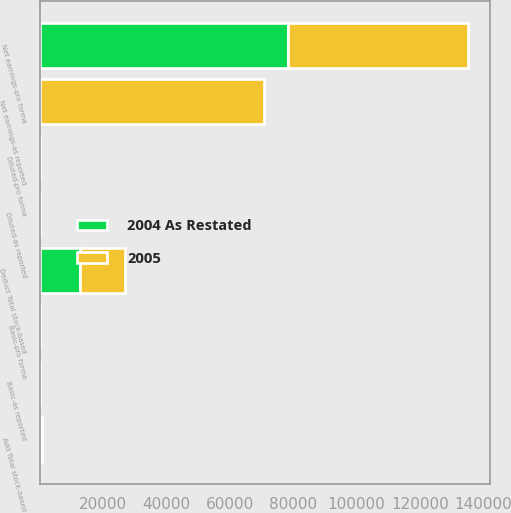Convert chart to OTSL. <chart><loc_0><loc_0><loc_500><loc_500><stacked_bar_chart><ecel><fcel>Net earnings-as reported<fcel>Add Total stock-based<fcel>Deduct Total stock-based<fcel>Net earnings-pro forma<fcel>Basic-as reported<fcel>Diluted-as reported<fcel>Basic-pro forma<fcel>Diluted-pro forma<nl><fcel>2004 As Restated<fcel>1.3<fcel>14<fcel>12554<fcel>78225<fcel>1.3<fcel>1.16<fcel>1.12<fcel>1.01<nl><fcel>2005<fcel>70644<fcel>632<fcel>14214<fcel>57062<fcel>1.05<fcel>0.93<fcel>0.84<fcel>0.76<nl></chart> 